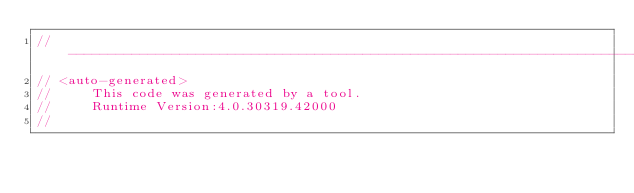<code> <loc_0><loc_0><loc_500><loc_500><_C#_>//------------------------------------------------------------------------------
// <auto-generated>
//     This code was generated by a tool.
//     Runtime Version:4.0.30319.42000
//</code> 